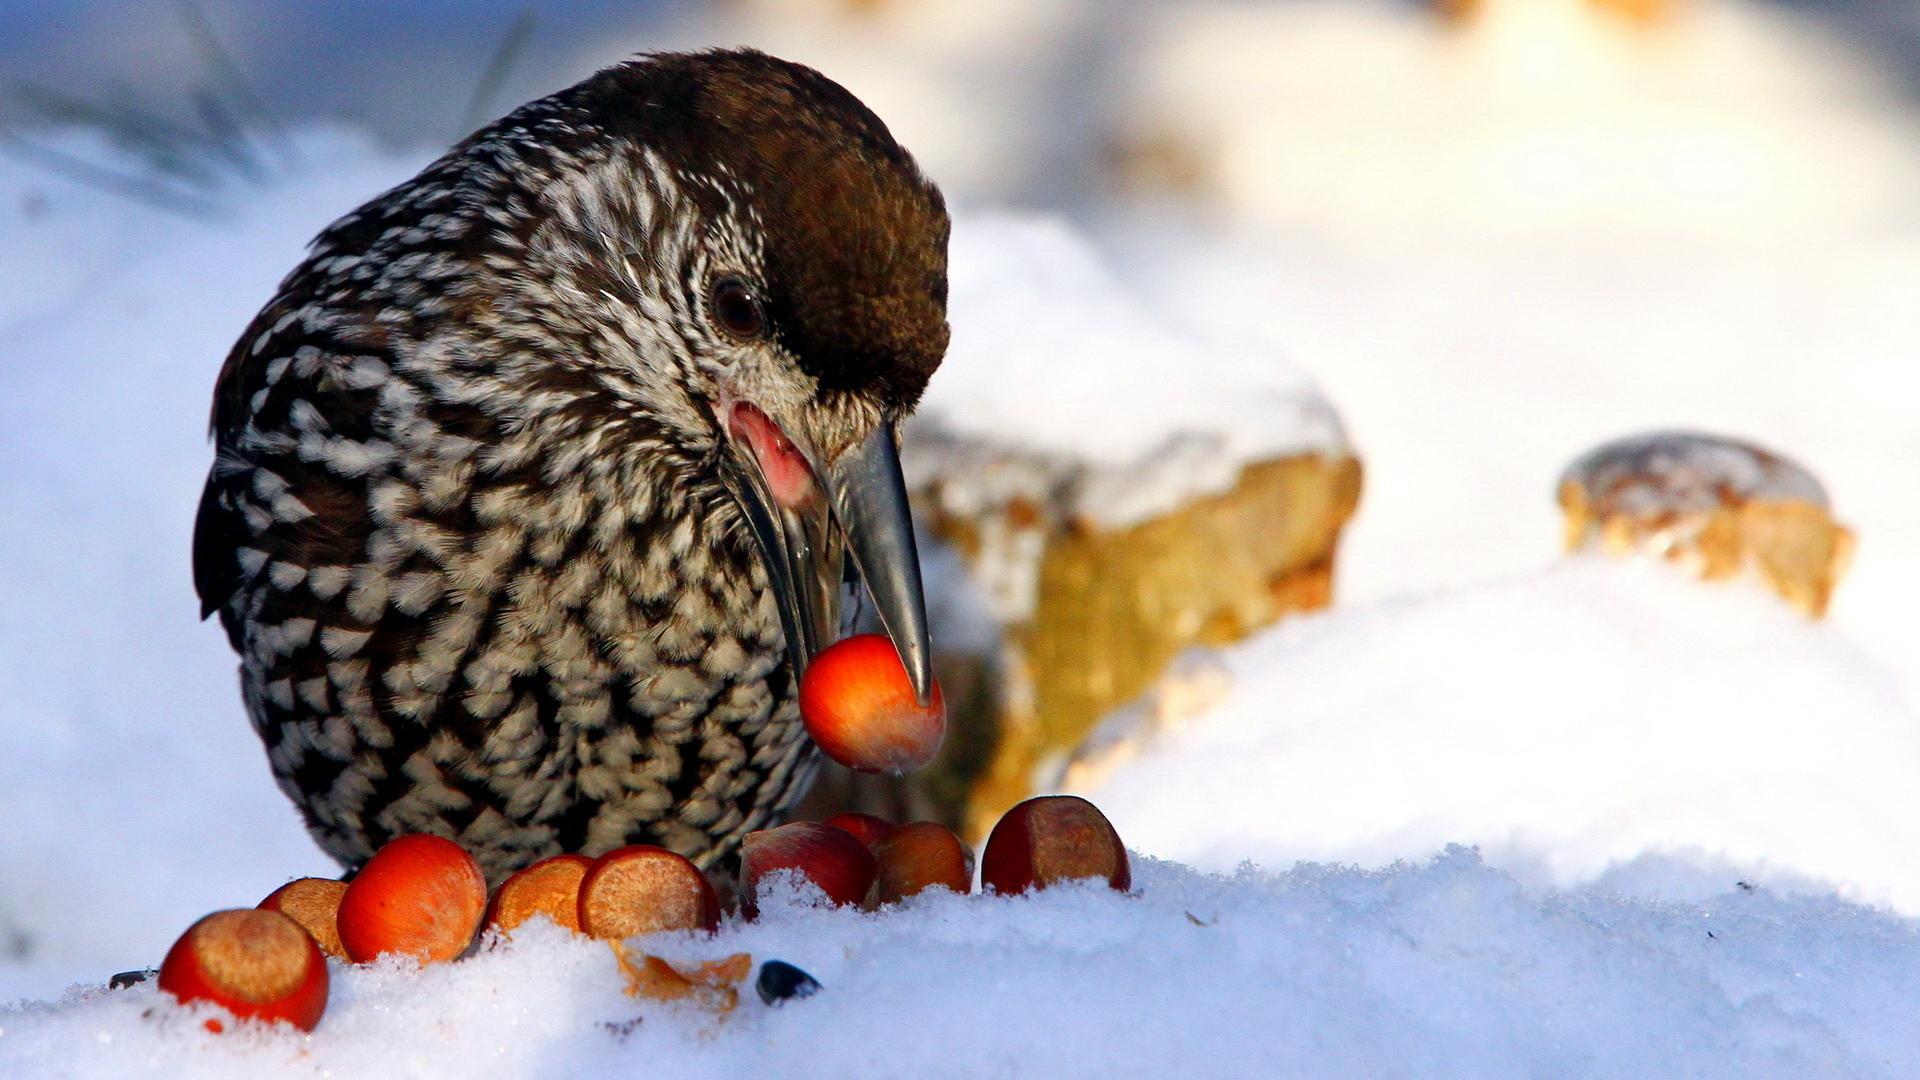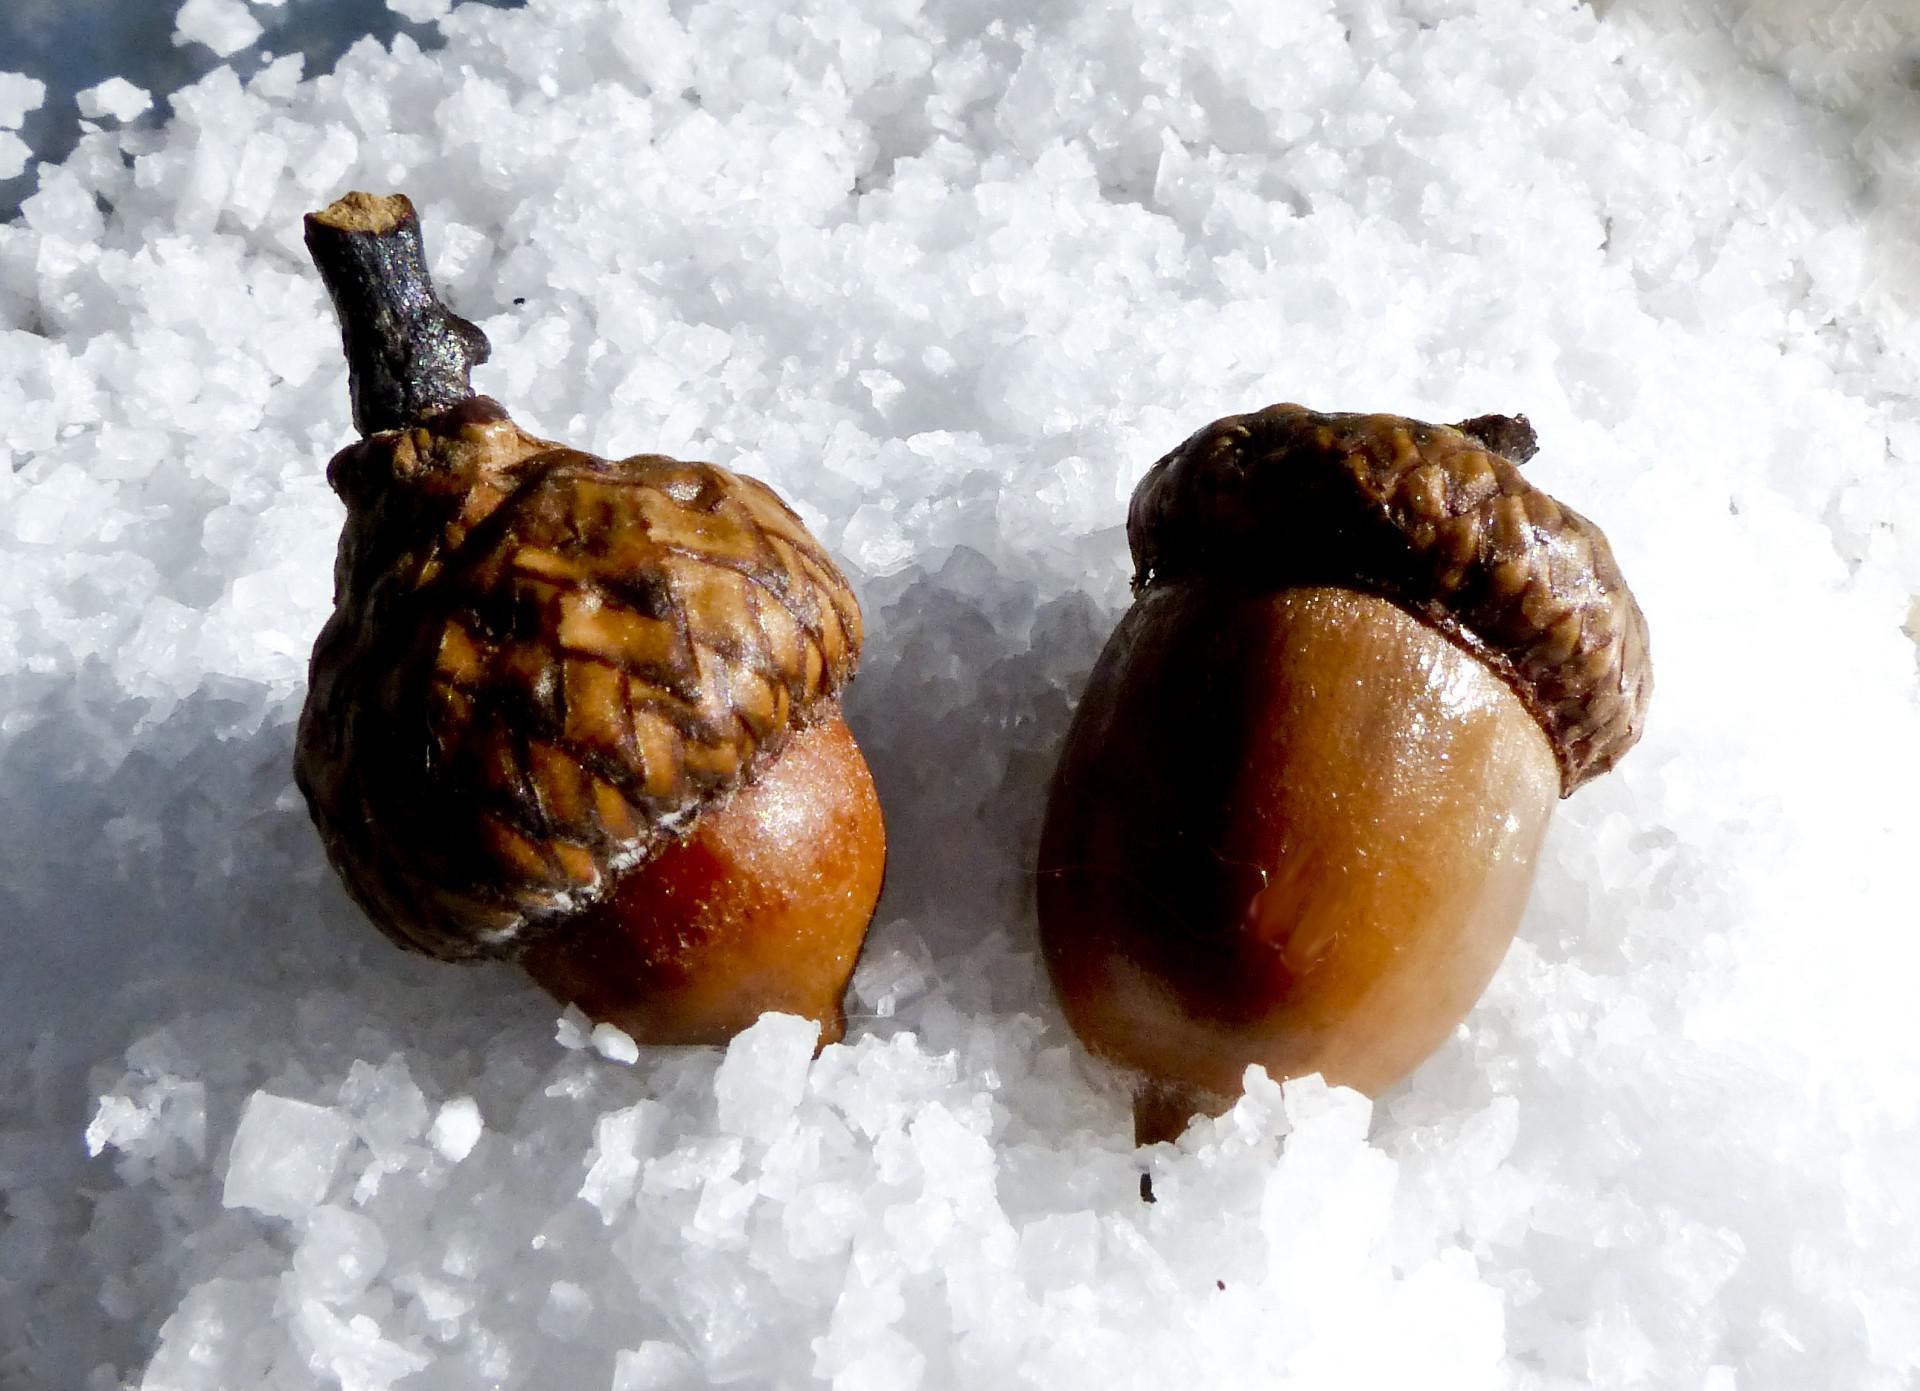The first image is the image on the left, the second image is the image on the right. Given the left and right images, does the statement "At least one image contains two real-looking side-by-side brown acorns with caps on." hold true? Answer yes or no. Yes. The first image is the image on the left, the second image is the image on the right. Analyze the images presented: Is the assertion "The left and right image contains a total of five arons." valid? Answer yes or no. No. 